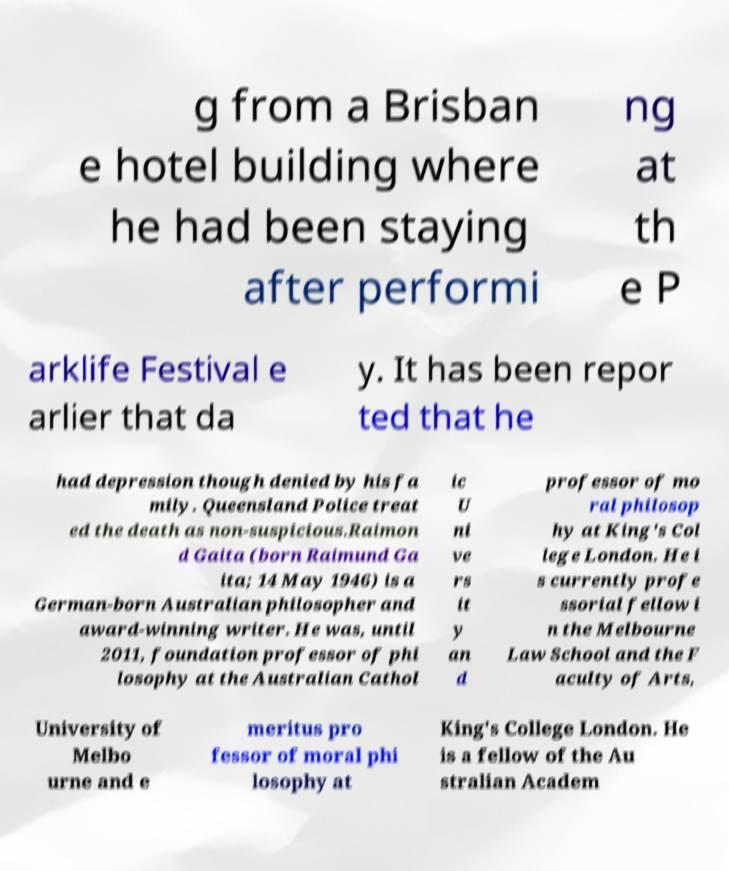Can you read and provide the text displayed in the image?This photo seems to have some interesting text. Can you extract and type it out for me? g from a Brisban e hotel building where he had been staying after performi ng at th e P arklife Festival e arlier that da y. It has been repor ted that he had depression though denied by his fa mily. Queensland Police treat ed the death as non-suspicious.Raimon d Gaita (born Raimund Ga ita; 14 May 1946) is a German-born Australian philosopher and award-winning writer. He was, until 2011, foundation professor of phi losophy at the Australian Cathol ic U ni ve rs it y an d professor of mo ral philosop hy at King's Col lege London. He i s currently profe ssorial fellow i n the Melbourne Law School and the F aculty of Arts, University of Melbo urne and e meritus pro fessor of moral phi losophy at King's College London. He is a fellow of the Au stralian Academ 